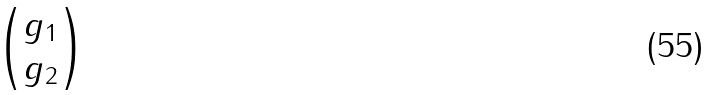<formula> <loc_0><loc_0><loc_500><loc_500>\begin{pmatrix} g _ { 1 } \\ g _ { 2 } \end{pmatrix}</formula> 